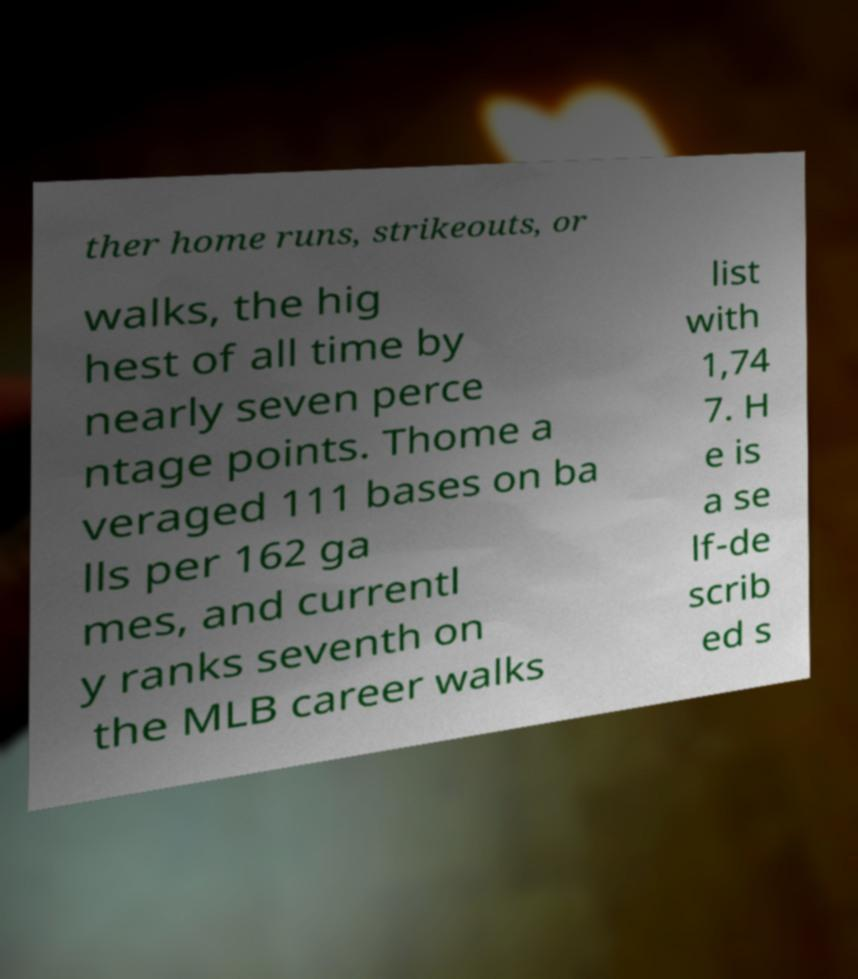Please read and relay the text visible in this image. What does it say? ther home runs, strikeouts, or walks, the hig hest of all time by nearly seven perce ntage points. Thome a veraged 111 bases on ba lls per 162 ga mes, and currentl y ranks seventh on the MLB career walks list with 1,74 7. H e is a se lf-de scrib ed s 